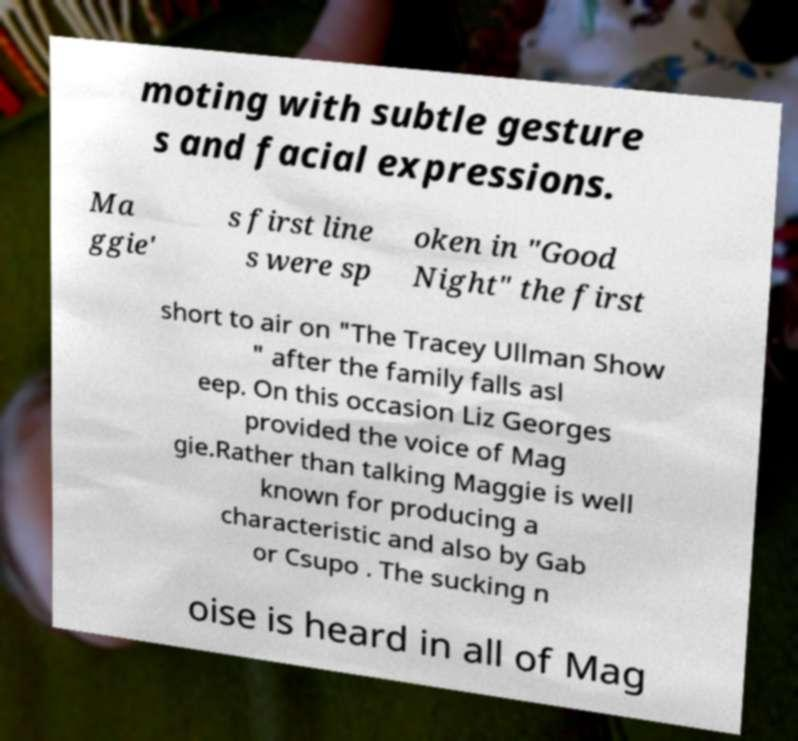What messages or text are displayed in this image? I need them in a readable, typed format. moting with subtle gesture s and facial expressions. Ma ggie' s first line s were sp oken in "Good Night" the first short to air on "The Tracey Ullman Show " after the family falls asl eep. On this occasion Liz Georges provided the voice of Mag gie.Rather than talking Maggie is well known for producing a characteristic and also by Gab or Csupo . The sucking n oise is heard in all of Mag 